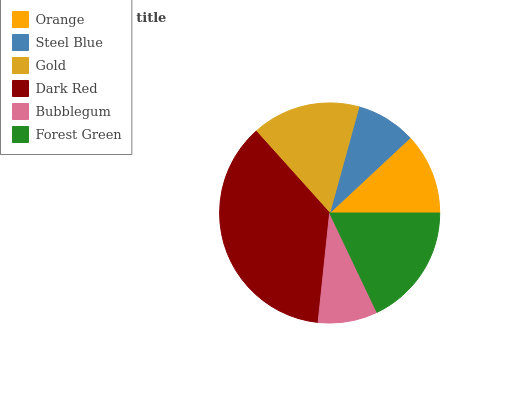Is Bubblegum the minimum?
Answer yes or no. Yes. Is Dark Red the maximum?
Answer yes or no. Yes. Is Steel Blue the minimum?
Answer yes or no. No. Is Steel Blue the maximum?
Answer yes or no. No. Is Orange greater than Steel Blue?
Answer yes or no. Yes. Is Steel Blue less than Orange?
Answer yes or no. Yes. Is Steel Blue greater than Orange?
Answer yes or no. No. Is Orange less than Steel Blue?
Answer yes or no. No. Is Gold the high median?
Answer yes or no. Yes. Is Orange the low median?
Answer yes or no. Yes. Is Bubblegum the high median?
Answer yes or no. No. Is Steel Blue the low median?
Answer yes or no. No. 